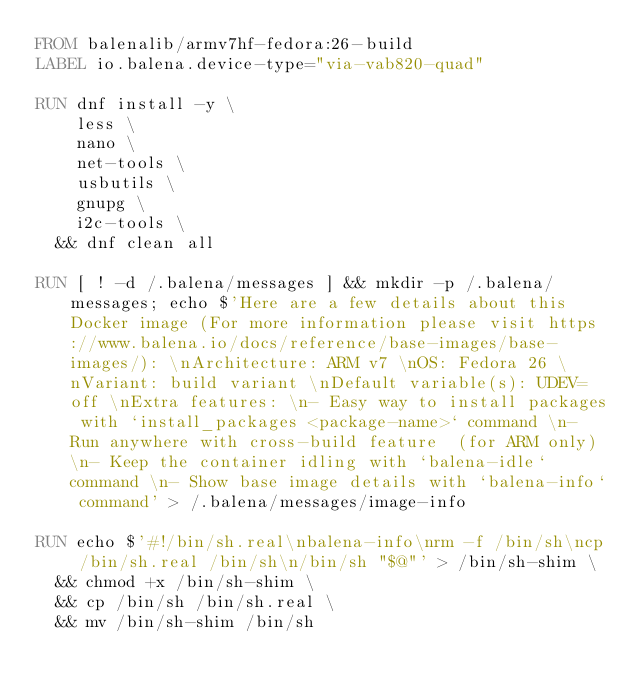Convert code to text. <code><loc_0><loc_0><loc_500><loc_500><_Dockerfile_>FROM balenalib/armv7hf-fedora:26-build
LABEL io.balena.device-type="via-vab820-quad"

RUN dnf install -y \
		less \
		nano \
		net-tools \
		usbutils \
		gnupg \
		i2c-tools \
	&& dnf clean all

RUN [ ! -d /.balena/messages ] && mkdir -p /.balena/messages; echo $'Here are a few details about this Docker image (For more information please visit https://www.balena.io/docs/reference/base-images/base-images/): \nArchitecture: ARM v7 \nOS: Fedora 26 \nVariant: build variant \nDefault variable(s): UDEV=off \nExtra features: \n- Easy way to install packages with `install_packages <package-name>` command \n- Run anywhere with cross-build feature  (for ARM only) \n- Keep the container idling with `balena-idle` command \n- Show base image details with `balena-info` command' > /.balena/messages/image-info

RUN echo $'#!/bin/sh.real\nbalena-info\nrm -f /bin/sh\ncp /bin/sh.real /bin/sh\n/bin/sh "$@"' > /bin/sh-shim \
	&& chmod +x /bin/sh-shim \
	&& cp /bin/sh /bin/sh.real \
	&& mv /bin/sh-shim /bin/sh</code> 